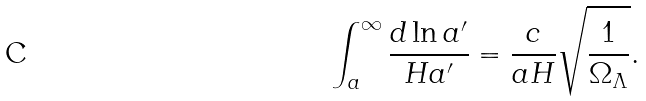Convert formula to latex. <formula><loc_0><loc_0><loc_500><loc_500>\int ^ { \infty } _ { a } \frac { d \ln a ^ { \prime } } { H a ^ { \prime } } = \frac { c } { a H } \sqrt { \frac { 1 } { \Omega _ { \Lambda } } } .</formula> 